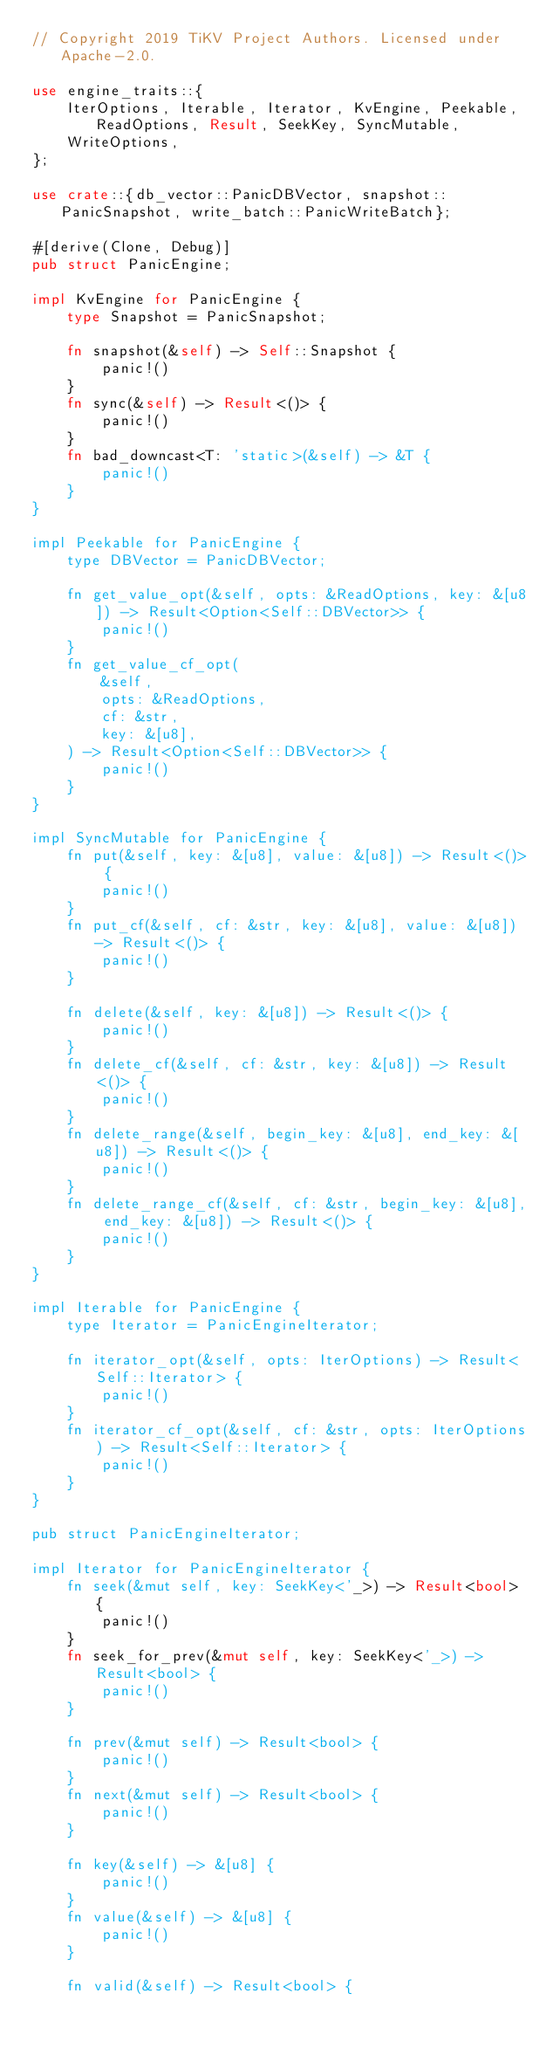<code> <loc_0><loc_0><loc_500><loc_500><_Rust_>// Copyright 2019 TiKV Project Authors. Licensed under Apache-2.0.

use engine_traits::{
    IterOptions, Iterable, Iterator, KvEngine, Peekable, ReadOptions, Result, SeekKey, SyncMutable,
    WriteOptions,
};

use crate::{db_vector::PanicDBVector, snapshot::PanicSnapshot, write_batch::PanicWriteBatch};

#[derive(Clone, Debug)]
pub struct PanicEngine;

impl KvEngine for PanicEngine {
    type Snapshot = PanicSnapshot;

    fn snapshot(&self) -> Self::Snapshot {
        panic!()
    }
    fn sync(&self) -> Result<()> {
        panic!()
    }
    fn bad_downcast<T: 'static>(&self) -> &T {
        panic!()
    }
}

impl Peekable for PanicEngine {
    type DBVector = PanicDBVector;

    fn get_value_opt(&self, opts: &ReadOptions, key: &[u8]) -> Result<Option<Self::DBVector>> {
        panic!()
    }
    fn get_value_cf_opt(
        &self,
        opts: &ReadOptions,
        cf: &str,
        key: &[u8],
    ) -> Result<Option<Self::DBVector>> {
        panic!()
    }
}

impl SyncMutable for PanicEngine {
    fn put(&self, key: &[u8], value: &[u8]) -> Result<()> {
        panic!()
    }
    fn put_cf(&self, cf: &str, key: &[u8], value: &[u8]) -> Result<()> {
        panic!()
    }

    fn delete(&self, key: &[u8]) -> Result<()> {
        panic!()
    }
    fn delete_cf(&self, cf: &str, key: &[u8]) -> Result<()> {
        panic!()
    }
    fn delete_range(&self, begin_key: &[u8], end_key: &[u8]) -> Result<()> {
        panic!()
    }
    fn delete_range_cf(&self, cf: &str, begin_key: &[u8], end_key: &[u8]) -> Result<()> {
        panic!()
    }
}

impl Iterable for PanicEngine {
    type Iterator = PanicEngineIterator;

    fn iterator_opt(&self, opts: IterOptions) -> Result<Self::Iterator> {
        panic!()
    }
    fn iterator_cf_opt(&self, cf: &str, opts: IterOptions) -> Result<Self::Iterator> {
        panic!()
    }
}

pub struct PanicEngineIterator;

impl Iterator for PanicEngineIterator {
    fn seek(&mut self, key: SeekKey<'_>) -> Result<bool> {
        panic!()
    }
    fn seek_for_prev(&mut self, key: SeekKey<'_>) -> Result<bool> {
        panic!()
    }

    fn prev(&mut self) -> Result<bool> {
        panic!()
    }
    fn next(&mut self) -> Result<bool> {
        panic!()
    }

    fn key(&self) -> &[u8] {
        panic!()
    }
    fn value(&self) -> &[u8] {
        panic!()
    }

    fn valid(&self) -> Result<bool> {</code> 